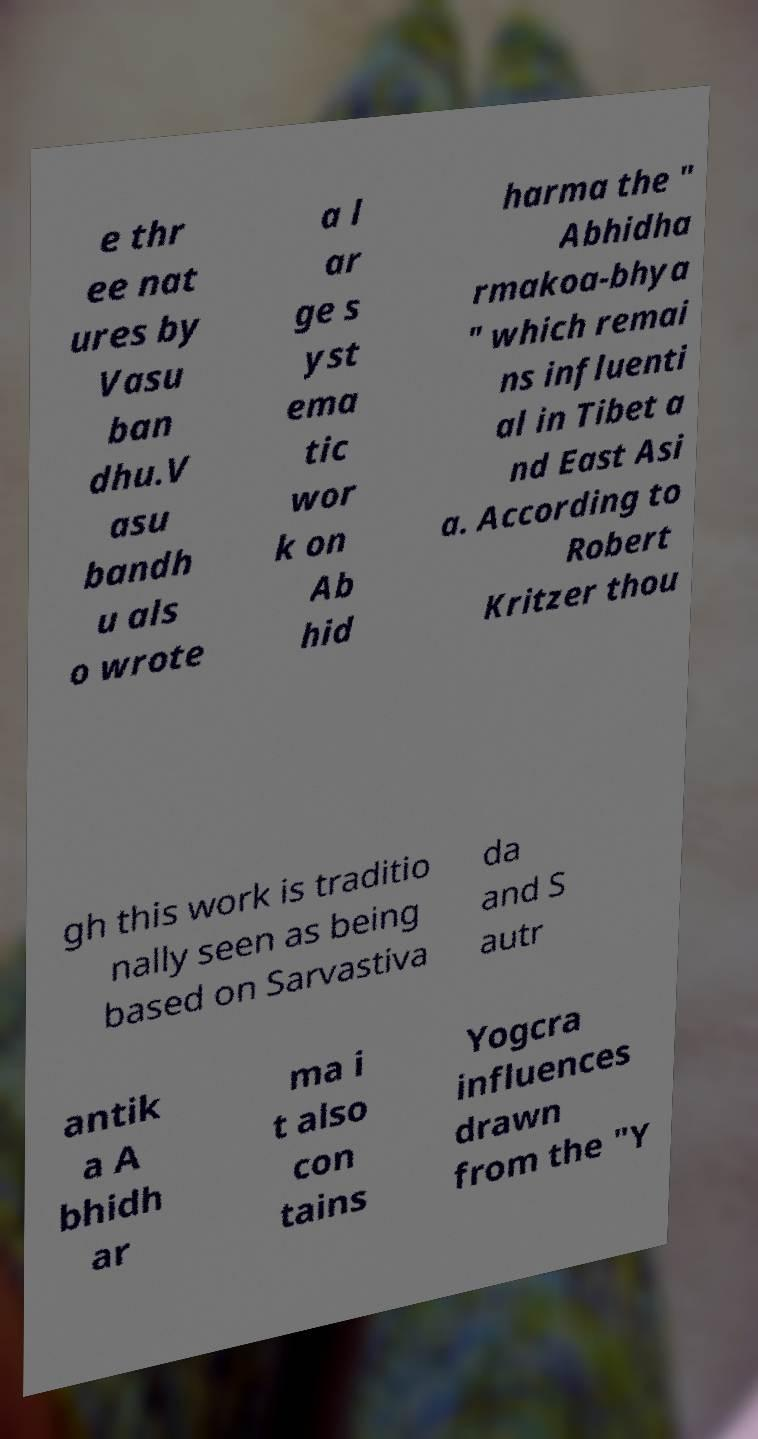Could you assist in decoding the text presented in this image and type it out clearly? e thr ee nat ures by Vasu ban dhu.V asu bandh u als o wrote a l ar ge s yst ema tic wor k on Ab hid harma the " Abhidha rmakoa-bhya " which remai ns influenti al in Tibet a nd East Asi a. According to Robert Kritzer thou gh this work is traditio nally seen as being based on Sarvastiva da and S autr antik a A bhidh ar ma i t also con tains Yogcra influences drawn from the "Y 